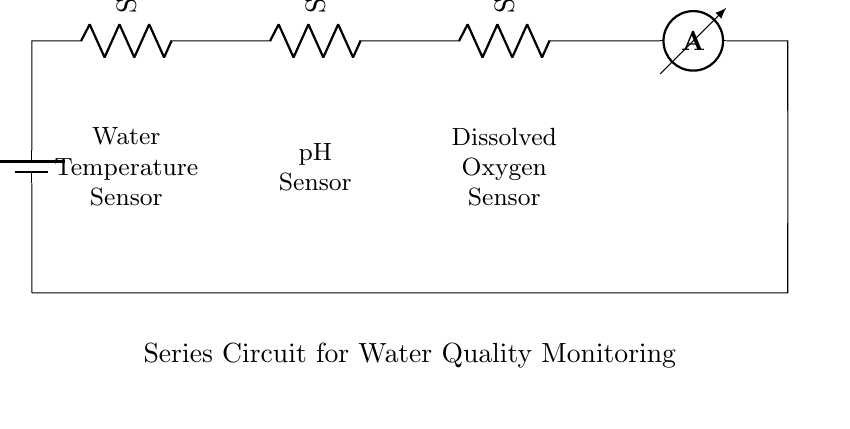What is the power source in this circuit? The power source in the circuit is represented by the battery symbol, which is labeled as V source. This indicates that it provides the necessary voltage for the operation of the sensors in the series circuit.
Answer: V source How many sensors are there in total? In the circuit diagram, there are three distinct sensors shown: the Water Temperature Sensor, the pH Sensor, and the Dissolved Oxygen Sensor. These sensors are connected in series, leading to a total count of three sensors.
Answer: 3 What is the measurement unit for current in this circuit? The current in this circuit is measured in amperes, as indicated by the ammeter symbol labeled I. This unit is standard for electric current measurement across circuits.
Answer: Amperes Which sensor measures pH levels? The pH Sensor is specifically labeled in the diagram, positioned between the Water Temperature Sensor and the Dissolved Oxygen Sensor, thus clearly indicating its role in measuring the pH levels of the water.
Answer: pH Sensor What happens to the current as it passes through multiple components in this series circuit? In a series circuit, the current remains constant throughout all components connected in sequence. Therefore, as the current flows through each sensor, it maintains the same value, dictated by the overall characteristics of the circuit.
Answer: Constant Can the current flow if one sensor fails in this series circuit? If one of the sensors fails (i.e., opens the circuit), the current will stop flowing completely because series circuits require all components to be functioning for the current to complete the path.
Answer: No 